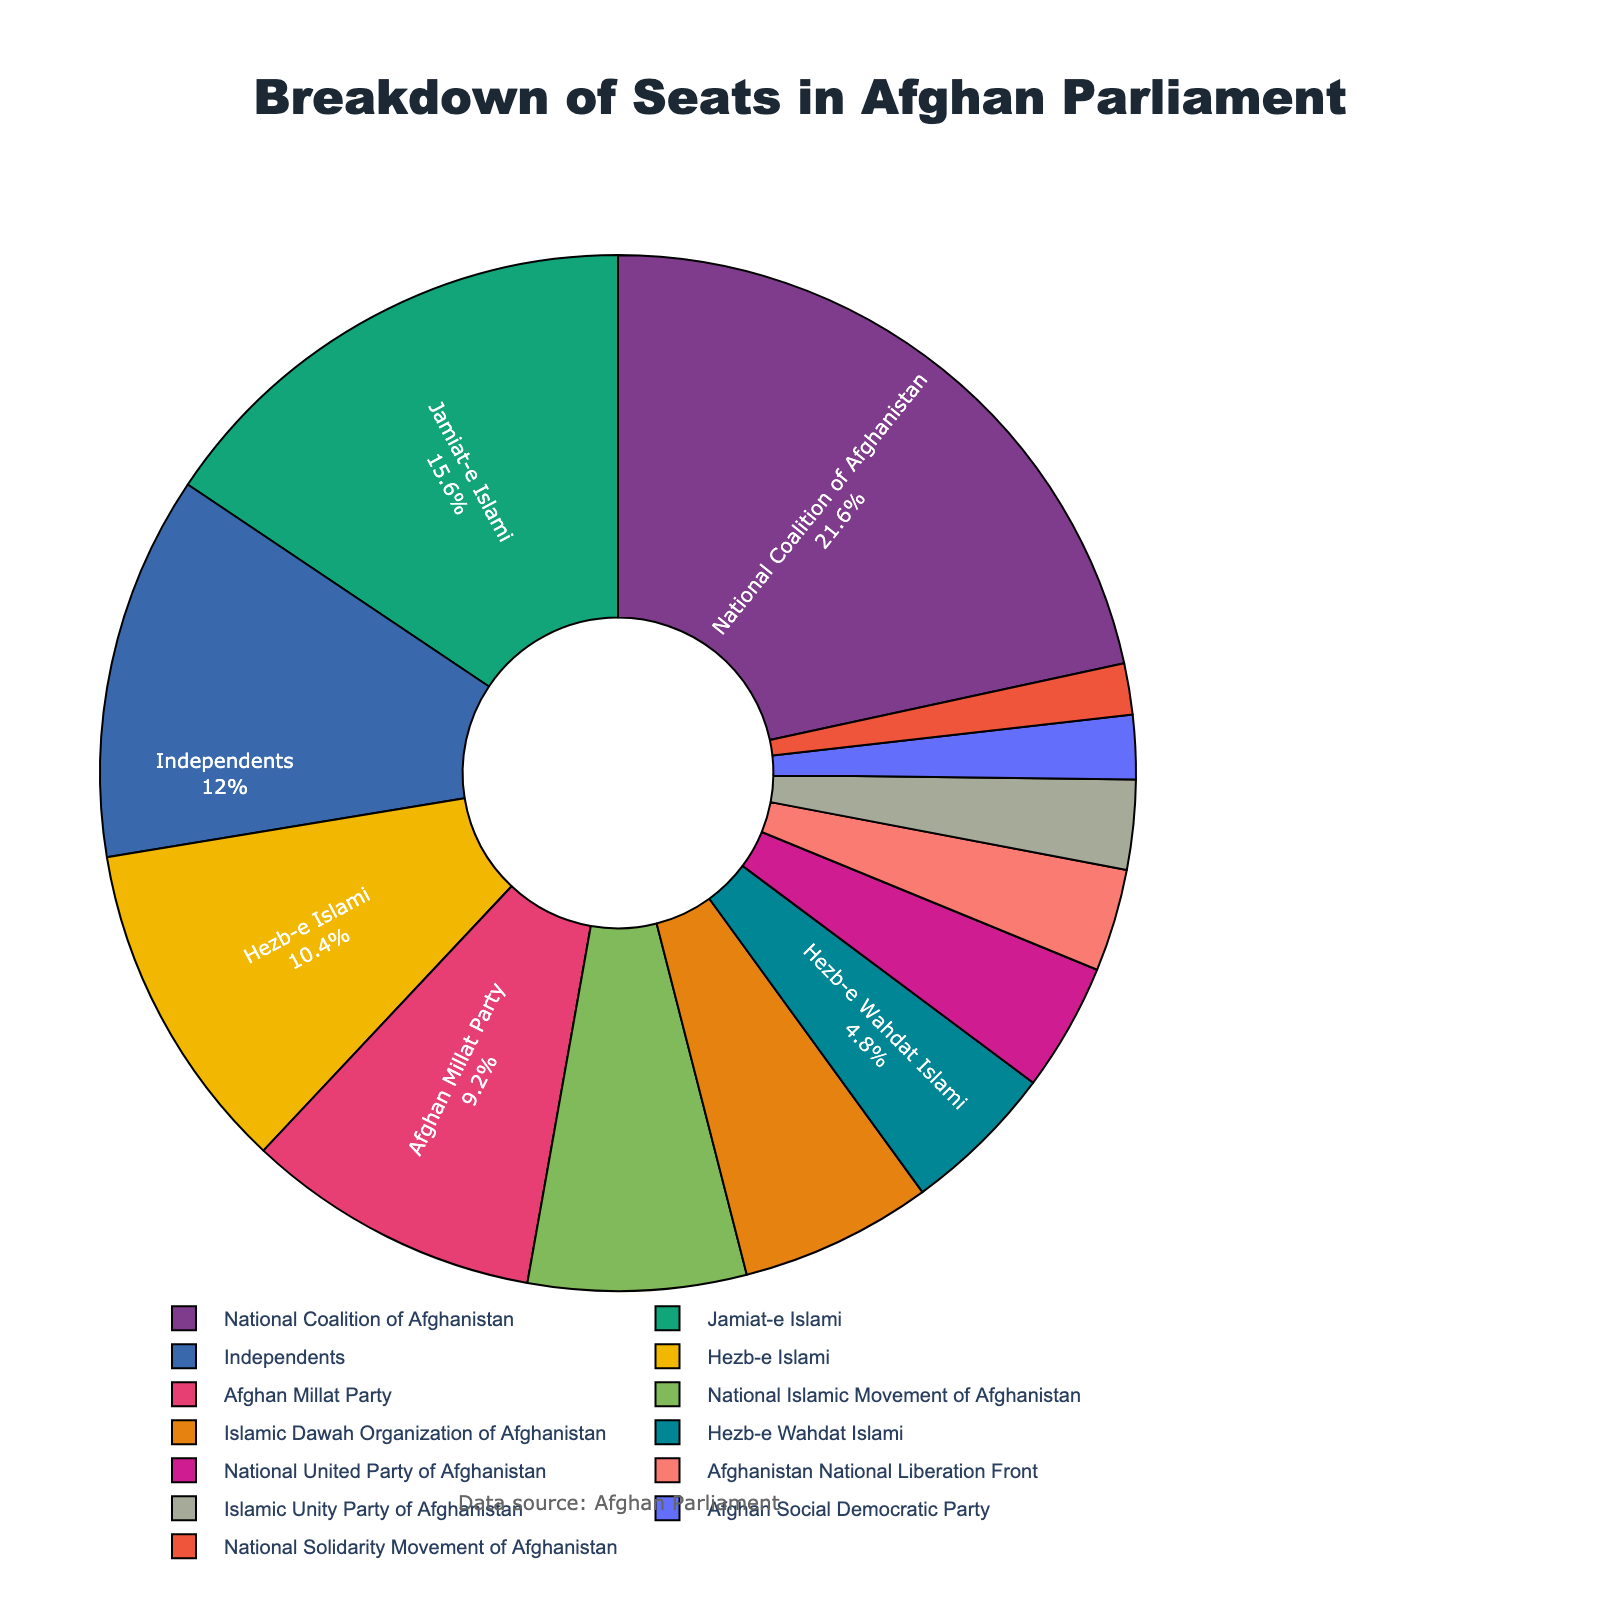What is the percentage of seats held by the National Coalition of Afghanistan? The pie chart shows the seats by percentage next to each party's label. Locate the National Coalition of Afghanistan and read the percentage value next to it, which is approximately 20%.
Answer: Approximately 20% How many more seats does the National Coalition of Afghanistan have compared to Jamiat-e Islami? Subtract the number of seats held by Jamiat-e Islami (39) from the seats held by the National Coalition of Afghanistan (54). The calculation is 54 - 39 = 15.
Answer: 15 seats What is the combined percentage of seats held by Hezb-e Islami, Afghan Millat Party, and National Islamic Movement of Afghanistan? Add together the percentage values for these three parties from the pie chart. These percentages are approximately 9% (Hezb-e Islami), 8% (Afghan Millat Party), and 6% (National Islamic Movement of Afghanistan). So, the combined percentage is 9% + 8% + 6% = 23%.
Answer: Approximately 23% Which party holds more seats: Islamic Dawah Organization of Afghanistan or Independents? Compare the number of seats between the Islamic Dawah Organization of Afghanistan (15 seats) and Independents (30 seats). Independents hold more seats.
Answer: Independents What is the color used to represent Hezb-e Wahdat Islami? Identify the segment corresponding to Hezb-e Wahdat Islami in the pie chart and note its color.
Answer: This requires visual identification from the chart; typically, you'd refer to the color seen How many parties have 10 or fewer seats in the Afghan parliament? Count the parties represented in the pie chart that have 10 or fewer seats based on the labels: National United Party of Afghanistan (10), Afghanistan National Liberation Front (8), Islamic Unity Party of Afghanistan (7), Afghan Social Democratic Party (5), National Solidarity Movement of Afghanistan (4). There are 5 such parties.
Answer: 5 parties What is the percentage difference between the seats held by Independents and the National Islamic Movement of Afghanistan? Calculate the difference in the number of seats, which is 30 (Independents) - 17 (National Islamic Movement of Afghanistan) = 13. Then find the percentage difference relative to the total seats (249). (13/249) ≈ 5.22%.
Answer: Approximately 5.22% Who holds a larger share of seats, the Islamic Unity Party of Afghanistan or the National Solidarity Movement of Afghanistan? Compare the seat numbers: Islamic Unity Party of Afghanistan (7 seats) and National Solidarity Movement of Afghanistan (4 seats). The Islamic Unity Party of Afghanistan has more seats.
Answer: Islamic Unity Party of Afghanistan Calculate the average number of seats held by the Afghan Millat Party, Hezb-e Wahdat Islami, and National United Party of Afghanistan. Add the seats: Afghan Millat Party (23), Hezb-e Wahdat Islami (12), and National United Party of Afghanistan (10). Sum: 23 + 12 + 10 = 45. Then divide by the number of parties, 45 / 3 = 15.
Answer: 15 seats Which party has a closer percentage of seats to the Afghan Social Democratic Party, the National Islamic Movement of Afghanistan, or Islamic Dawah Organization of Afghanistan? Compare the percentages: National Islamic Movement of Afghanistan (approximately 6%) and Islamic Dawah Organization of Afghanistan (approximately 5%) with Afghan Social Democratic Party (approximately 2%). The National Islamic Movement of Afghanistan percentage is closer.
Answer: National Islamic Movement of Afghanistan 